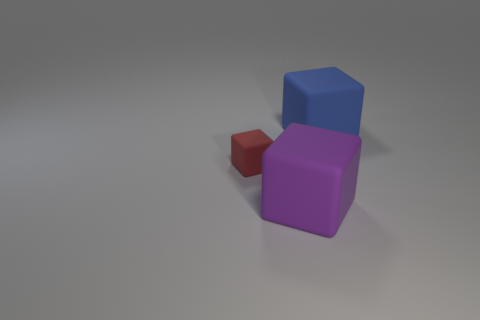Add 1 blocks. How many objects exist? 4 Add 3 purple rubber cubes. How many purple rubber cubes exist? 4 Subtract 0 cyan cylinders. How many objects are left? 3 Subtract all small red objects. Subtract all big matte objects. How many objects are left? 0 Add 2 big purple matte objects. How many big purple matte objects are left? 3 